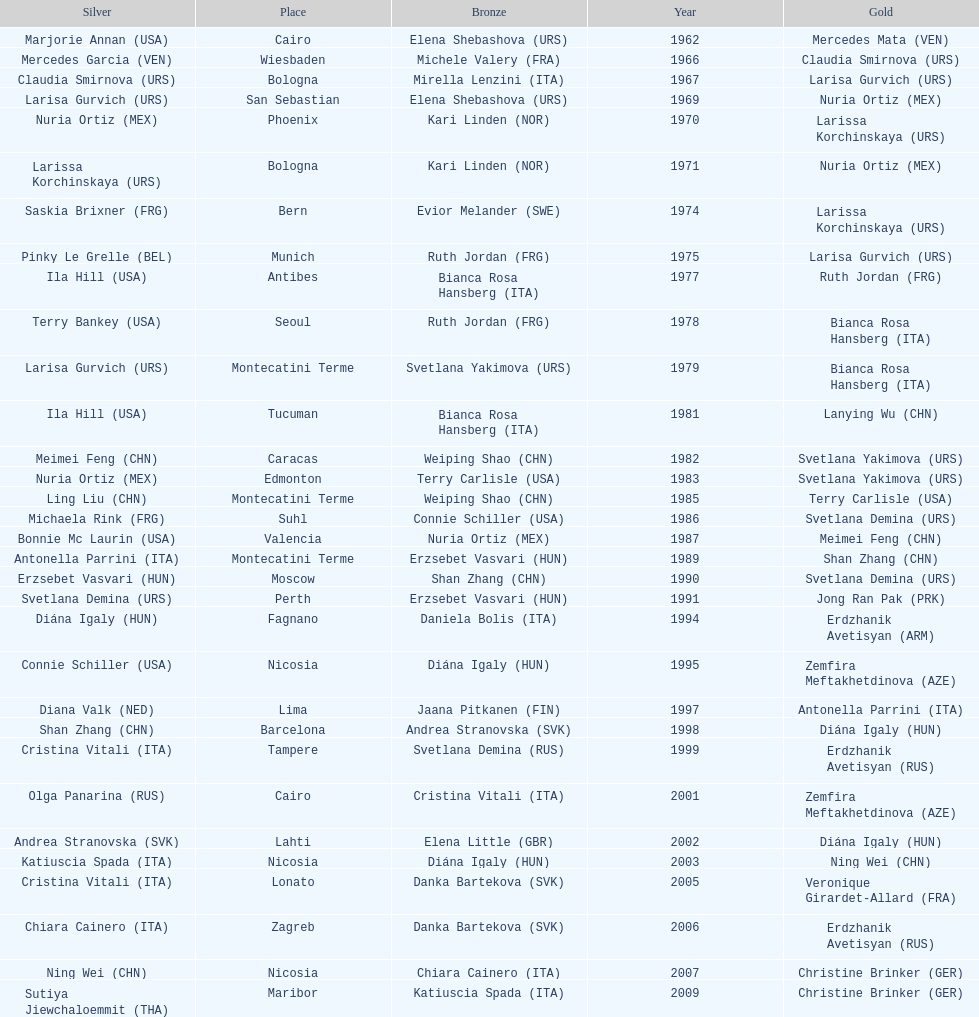Which country has the most bronze medals? Italy. 